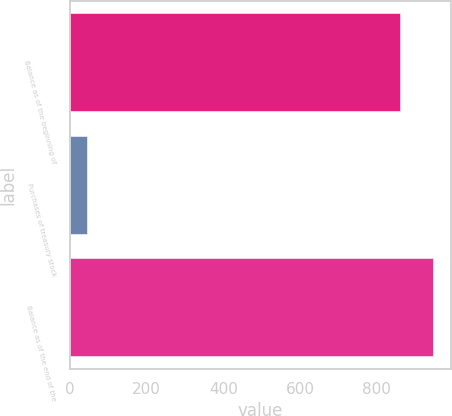<chart> <loc_0><loc_0><loc_500><loc_500><bar_chart><fcel>Balance as of the beginning of<fcel>Purchases of treasury stock<fcel>Balance as of the end of the<nl><fcel>860<fcel>45<fcel>946<nl></chart> 